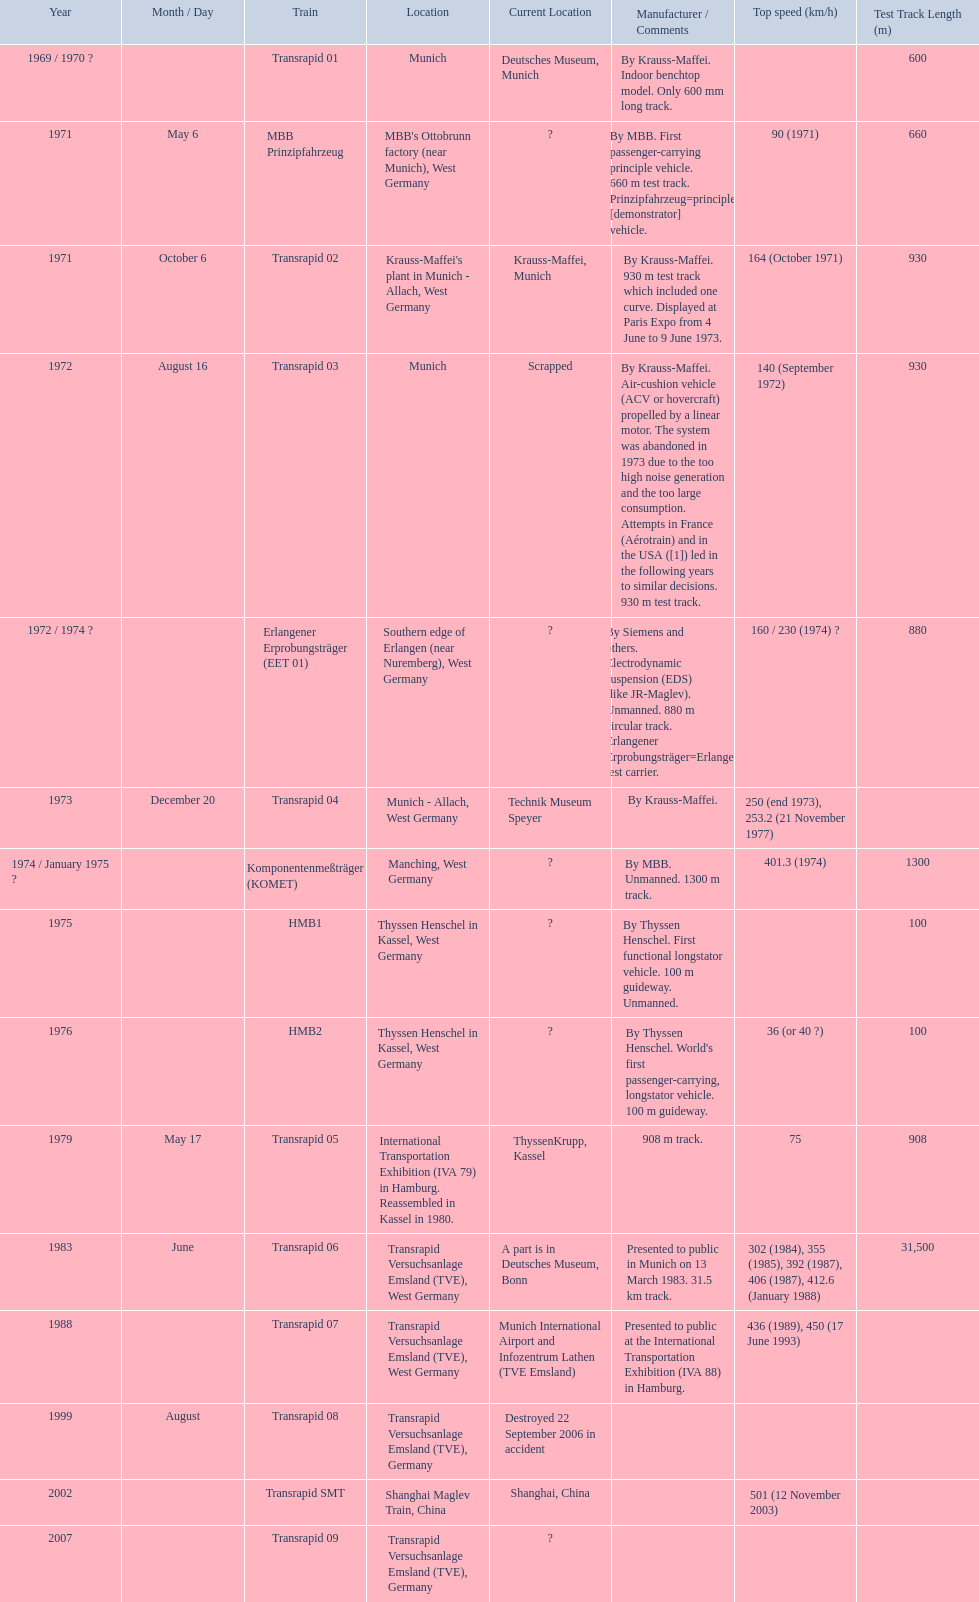Which trains had a top speed listed? MBB Prinzipfahrzeug, Transrapid 02, Transrapid 03, Erlangener Erprobungsträger (EET 01), Transrapid 04, Komponentenmeßträger (KOMET), HMB2, Transrapid 05, Transrapid 06, Transrapid 07, Transrapid SMT. Which ones list munich as a location? MBB Prinzipfahrzeug, Transrapid 02, Transrapid 03. Of these which ones present location is known? Transrapid 02, Transrapid 03. Which of those is no longer in operation? Transrapid 03. 